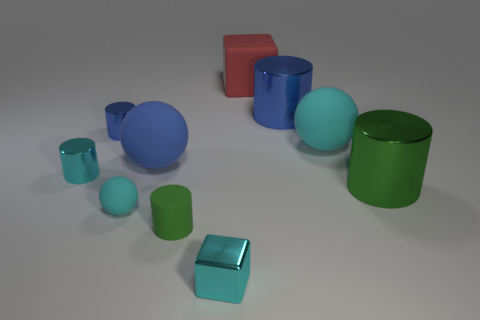Subtract 3 cylinders. How many cylinders are left? 2 Subtract all blue blocks. Subtract all yellow balls. How many blocks are left? 2 Subtract all yellow blocks. How many gray balls are left? 0 Subtract all cyan metallic things. Subtract all large blue rubber balls. How many objects are left? 7 Add 6 large metal cylinders. How many large metal cylinders are left? 8 Add 2 metal objects. How many metal objects exist? 7 Subtract all cyan cylinders. How many cylinders are left? 4 Subtract all metallic cylinders. How many cylinders are left? 1 Subtract 0 red cylinders. How many objects are left? 10 Subtract all cubes. How many objects are left? 8 